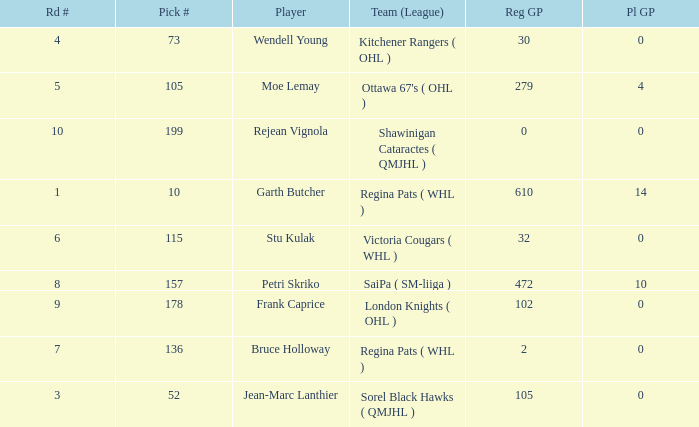What is the total number of Pl GP when the pick number is 199 and the Reg GP is bigger than 0? None. 